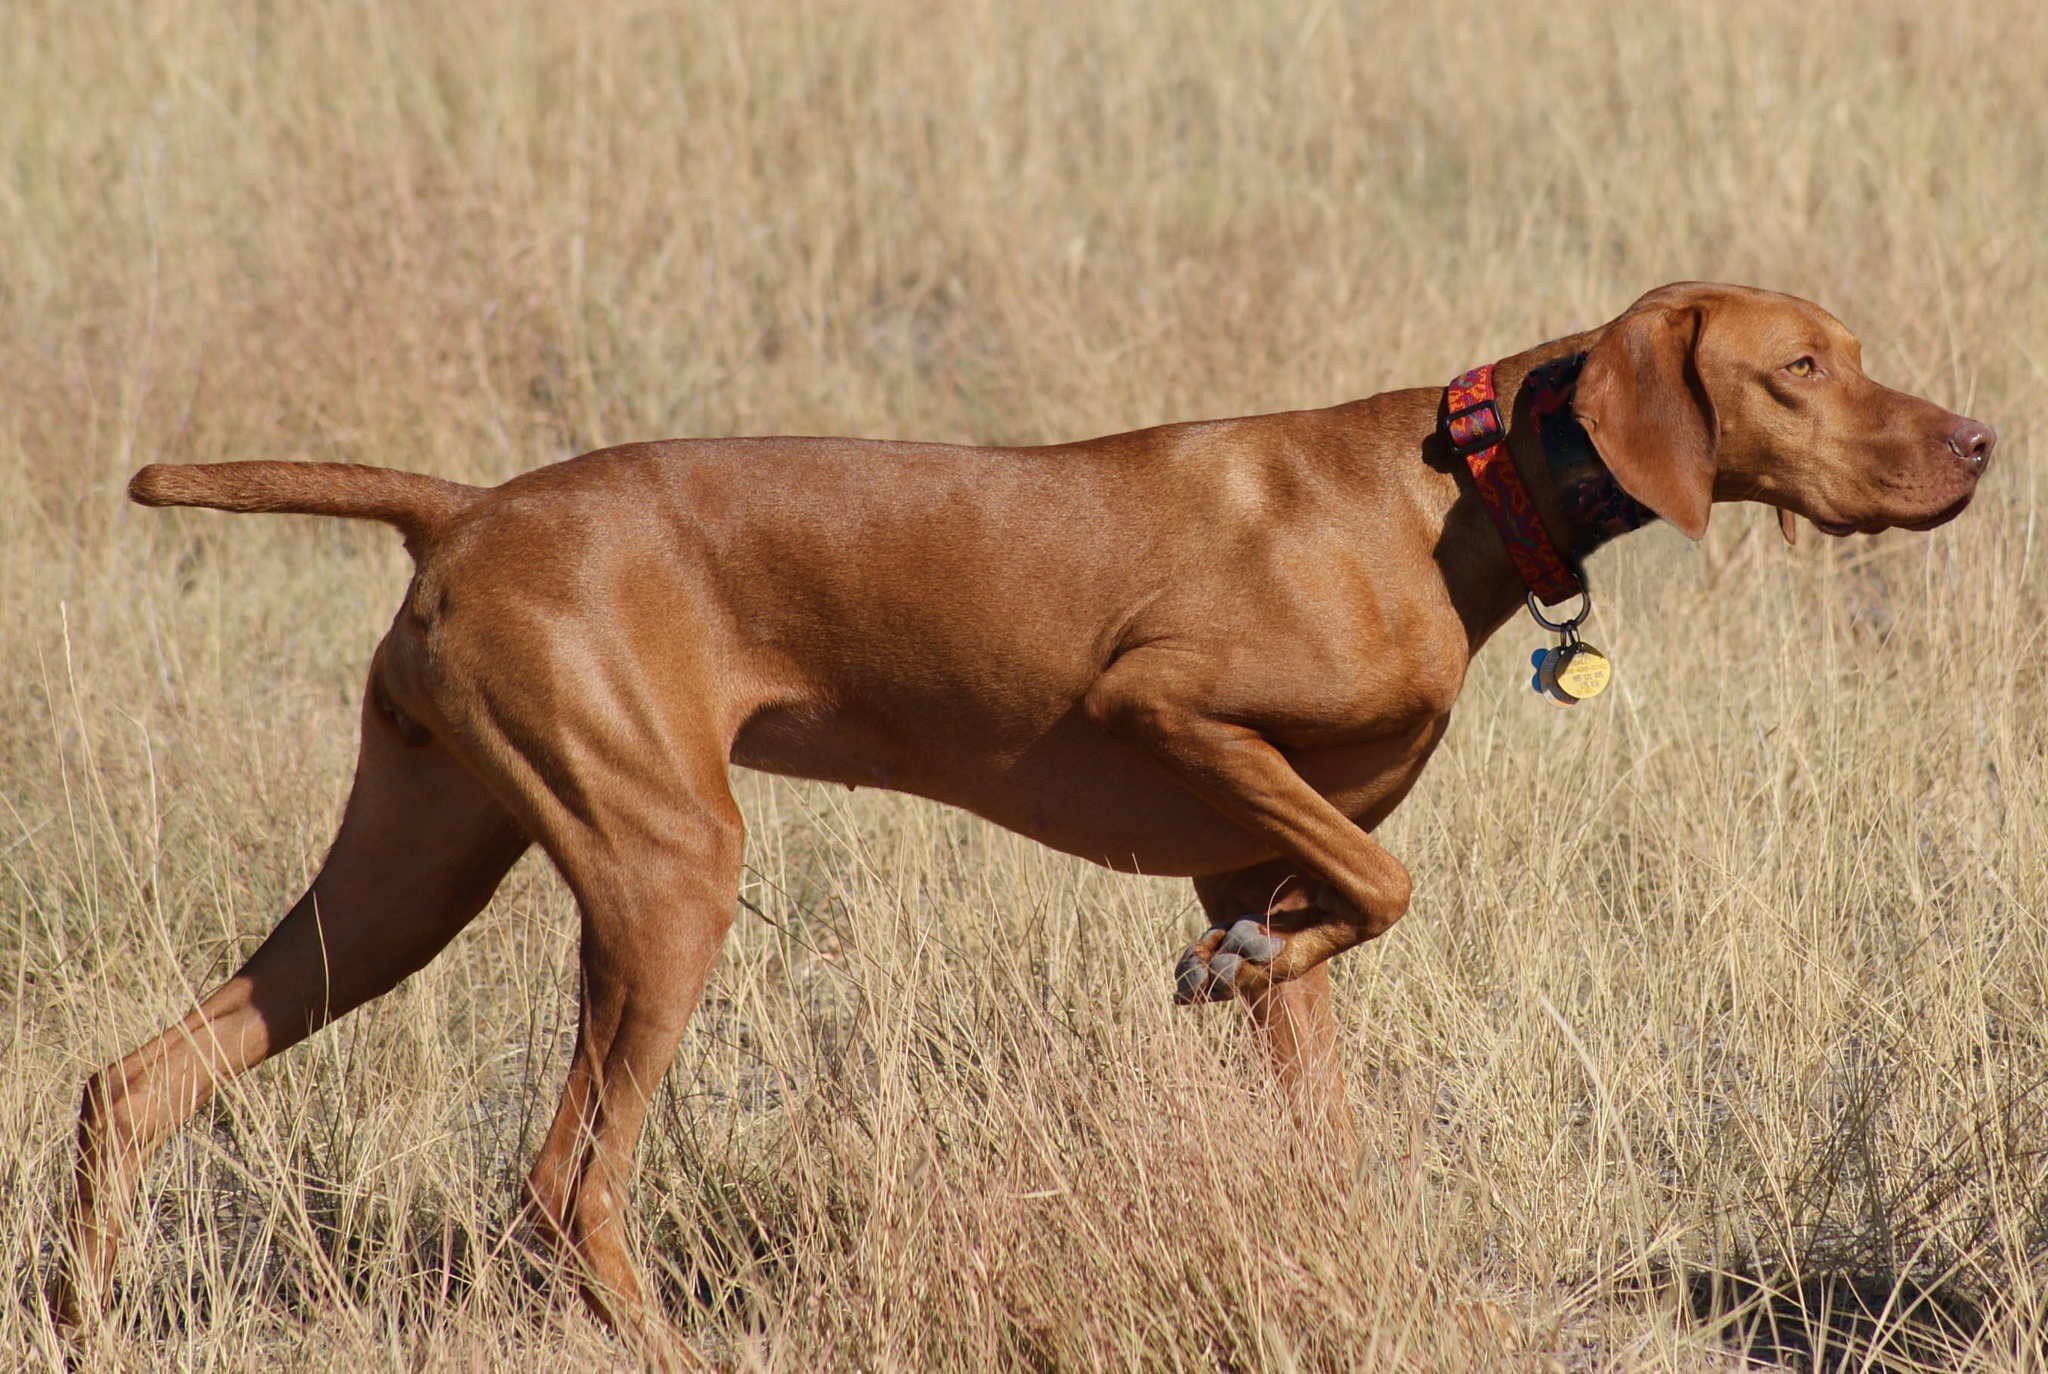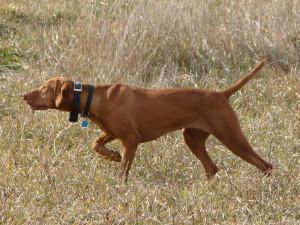The first image is the image on the left, the second image is the image on the right. For the images shown, is this caption "One of the images features a pair of dogs together." true? Answer yes or no. No. The first image is the image on the left, the second image is the image on the right. Given the left and right images, does the statement "In one image there is a single dog and in the other image there are 2 dogs." hold true? Answer yes or no. No. 